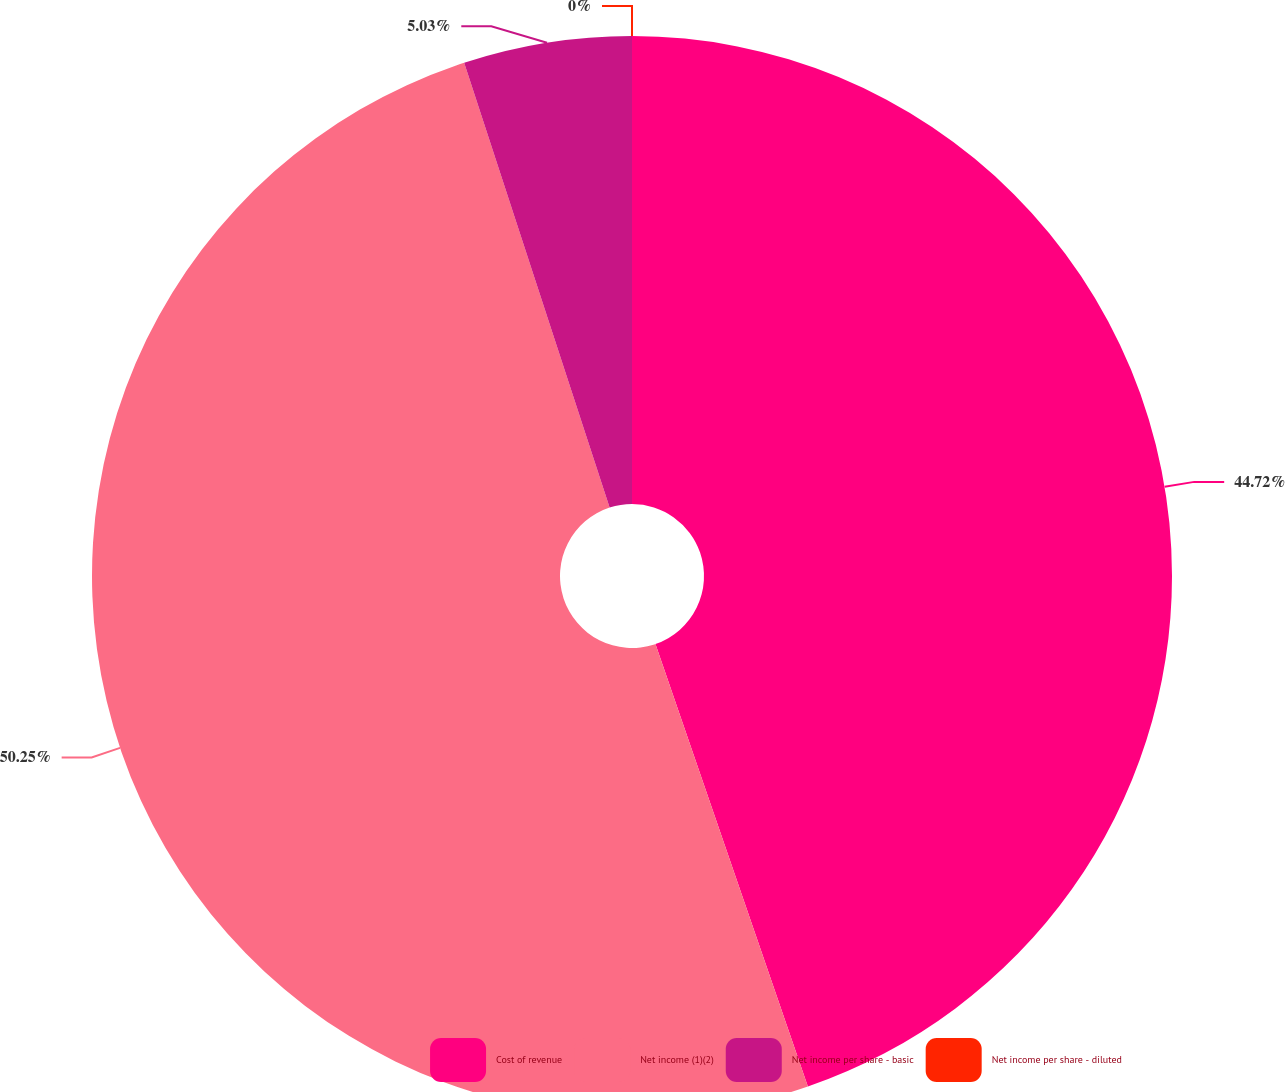Convert chart. <chart><loc_0><loc_0><loc_500><loc_500><pie_chart><fcel>Cost of revenue<fcel>Net income (1)(2)<fcel>Net income per share - basic<fcel>Net income per share - diluted<nl><fcel>44.72%<fcel>50.25%<fcel>5.03%<fcel>0.0%<nl></chart> 